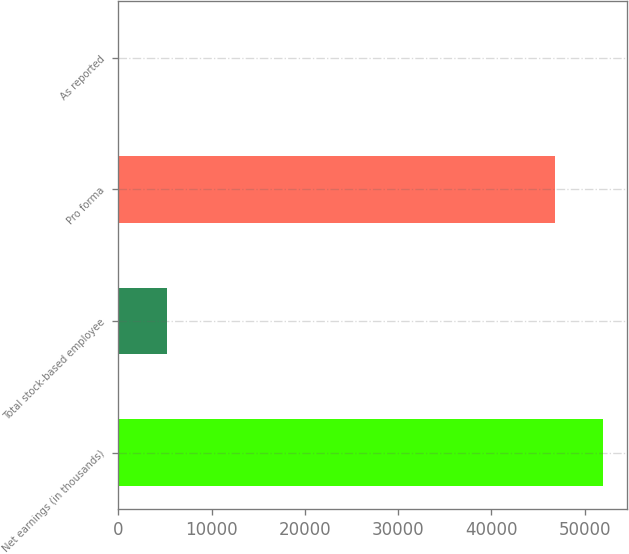Convert chart to OTSL. <chart><loc_0><loc_0><loc_500><loc_500><bar_chart><fcel>Net earnings (in thousands)<fcel>Total stock-based employee<fcel>Pro forma<fcel>As reported<nl><fcel>51989.5<fcel>5182.21<fcel>46808<fcel>0.68<nl></chart> 